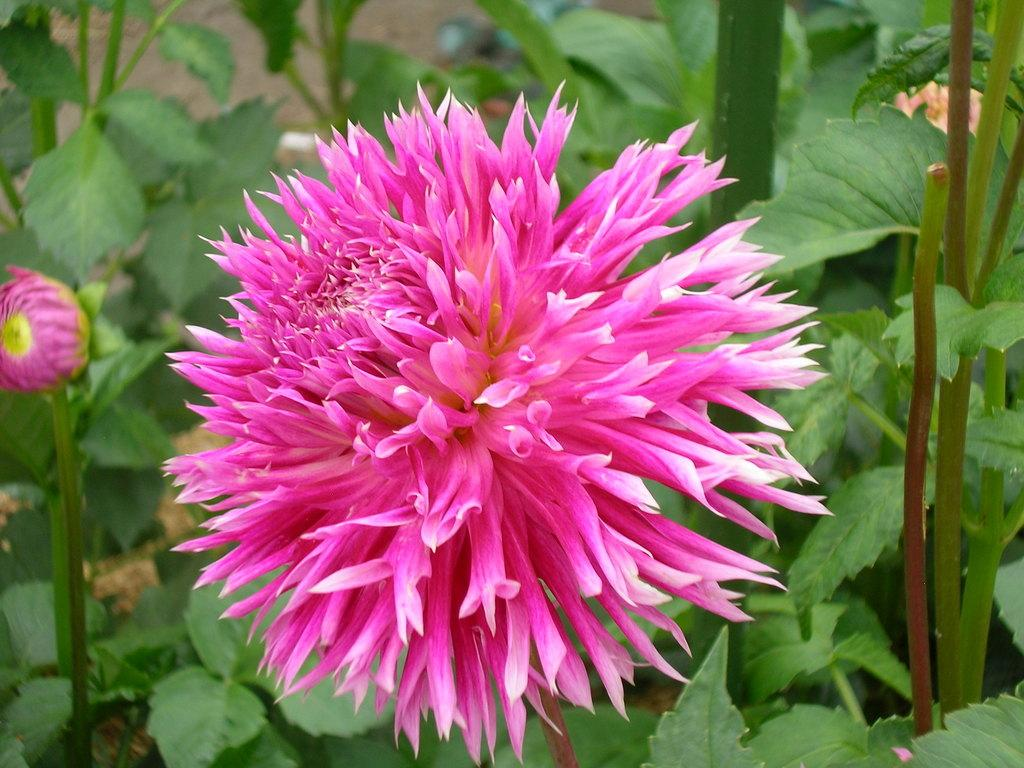What is the main subject in the foreground of the image? There is a pink flower in the foreground of the image. How would you describe the appearance of the flower? The flower is beautiful. Is the flower part of a larger plant? Yes, the flower is part of a plant. What can be seen in the background of the image? There are plants in the background of the image. What type of belief is depicted in the image? There is no depiction of a belief in the image; it features a pink flower and plants. Can you tell me how many yams are present in the image? There are no yams present in the image; it features a pink flower and plants. 